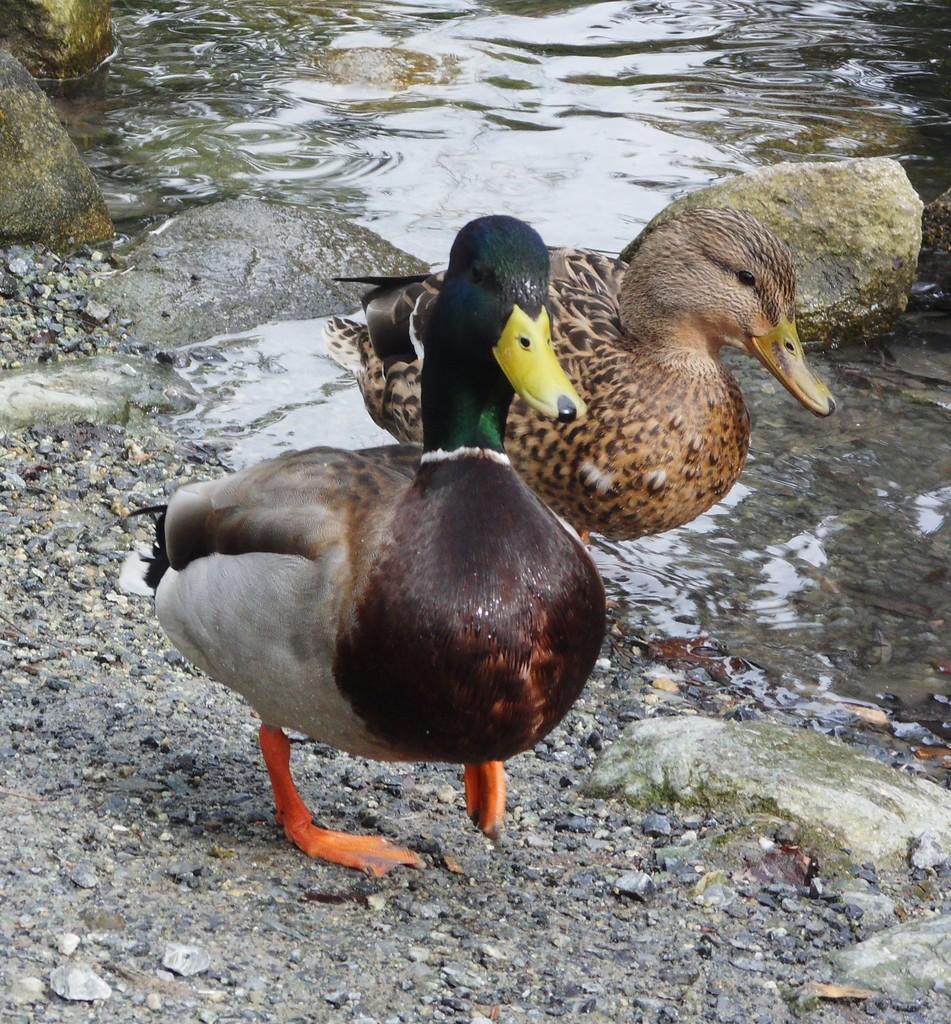Describe this image in one or two sentences. In this image, we can see ducks, stones, rocks and water. Here a duck is walking on the surface. 